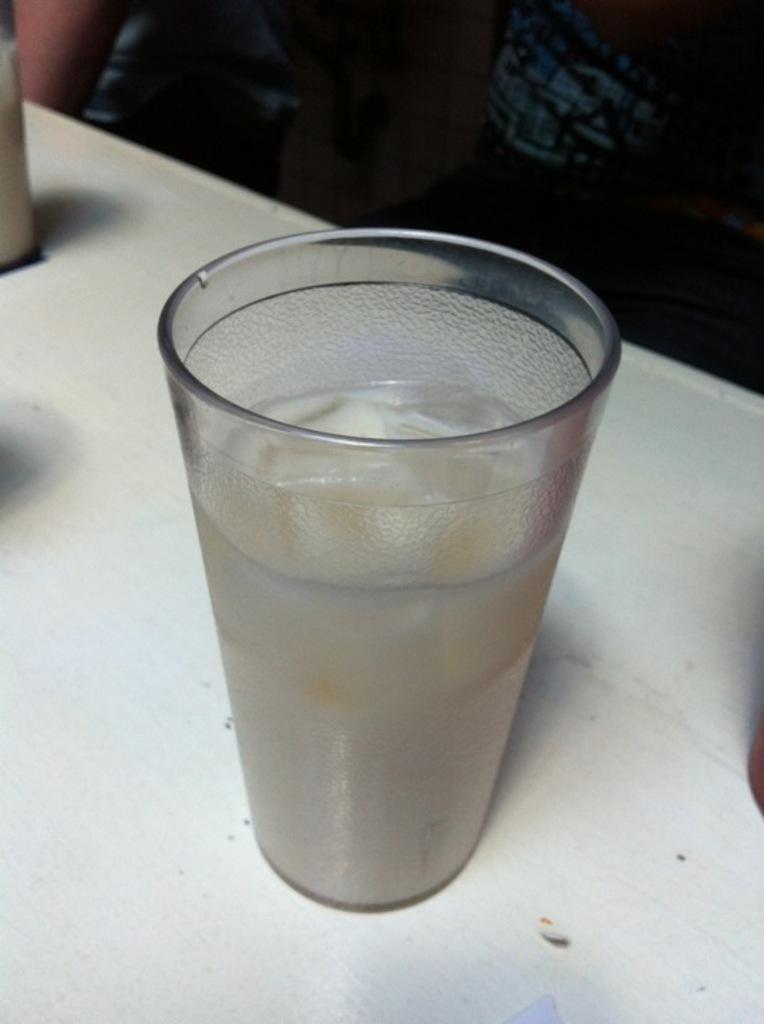Please provide a concise description of this image. In this image I can see a glass with a liquid on a table. 